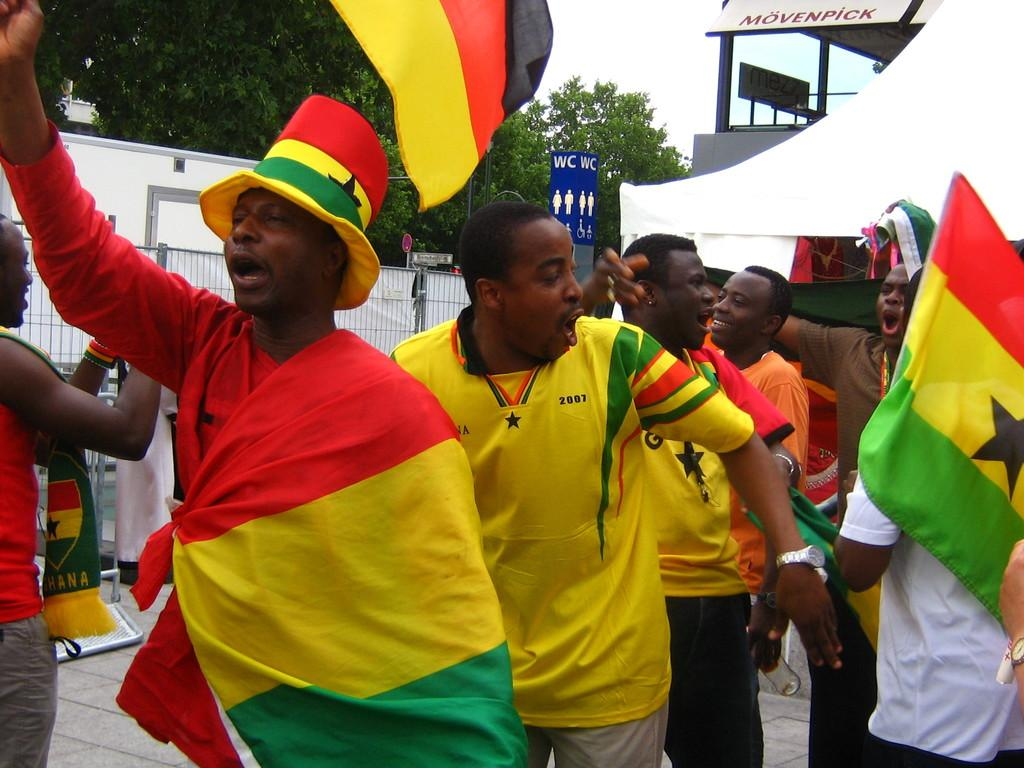What are the people in the image doing? The people in the image are standing and holding flags in their hands. What are the people wearing on their heads? The people are wearing hats. What can be seen in the background of the image? There are trees and a building visible in the background of the image. What type of trouble is the person in the image experiencing? There is no indication of trouble in the image; the people are standing and holding flags. What are the people learning in the image? There is no indication of learning in the image; the people are holding flags and wearing hats. 